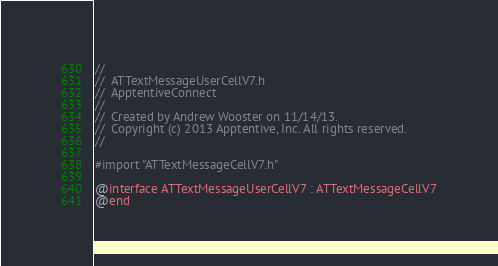<code> <loc_0><loc_0><loc_500><loc_500><_C_>//
//  ATTextMessageUserCellV7.h
//  ApptentiveConnect
//
//  Created by Andrew Wooster on 11/14/13.
//  Copyright (c) 2013 Apptentive, Inc. All rights reserved.
//

#import "ATTextMessageCellV7.h"

@interface ATTextMessageUserCellV7 : ATTextMessageCellV7
@end
</code> 